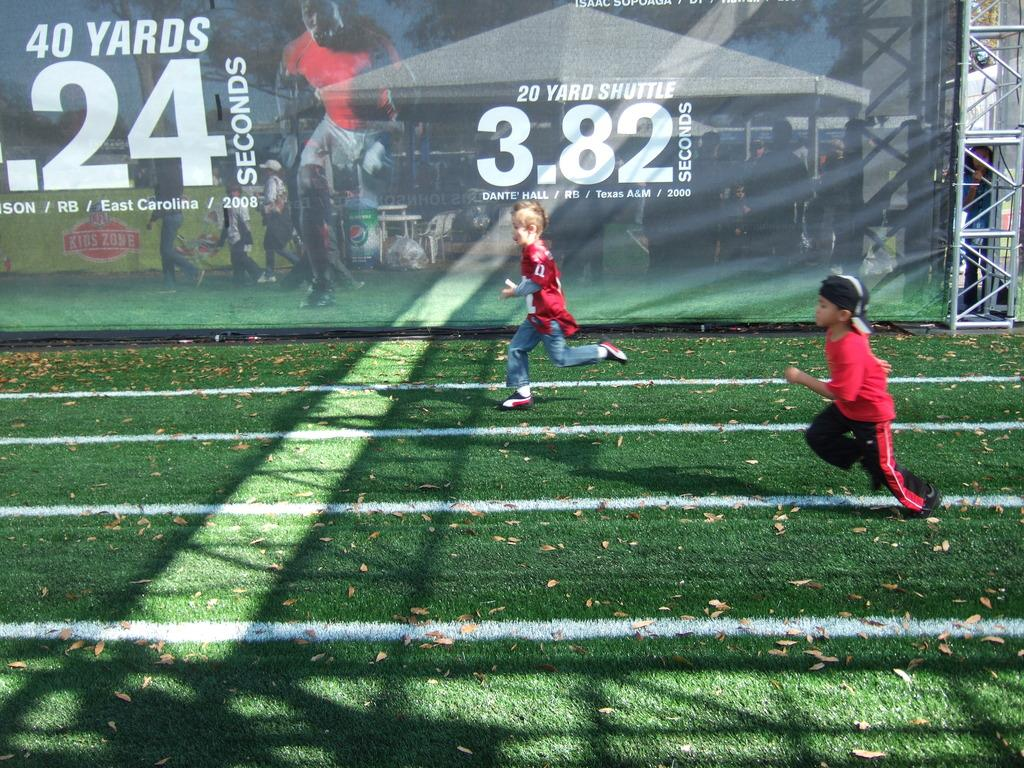<image>
Present a compact description of the photo's key features. some kids running passed an ad with 3.82 on it 